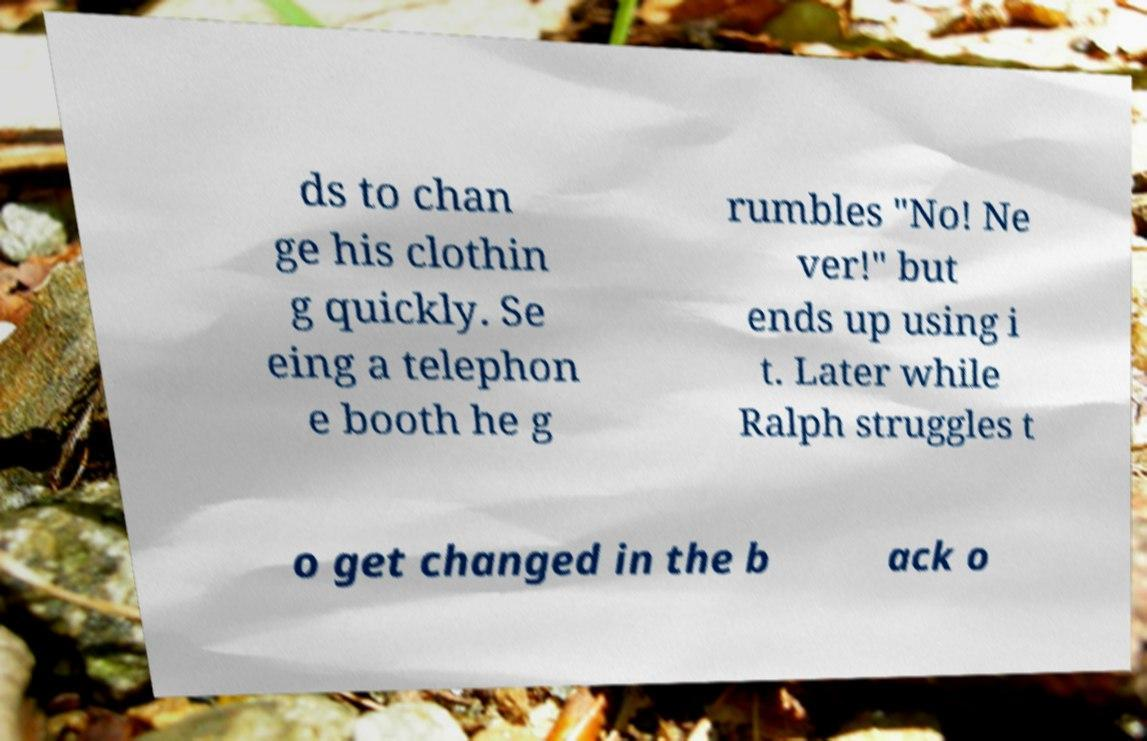Could you extract and type out the text from this image? ds to chan ge his clothin g quickly. Se eing a telephon e booth he g rumbles "No! Ne ver!" but ends up using i t. Later while Ralph struggles t o get changed in the b ack o 